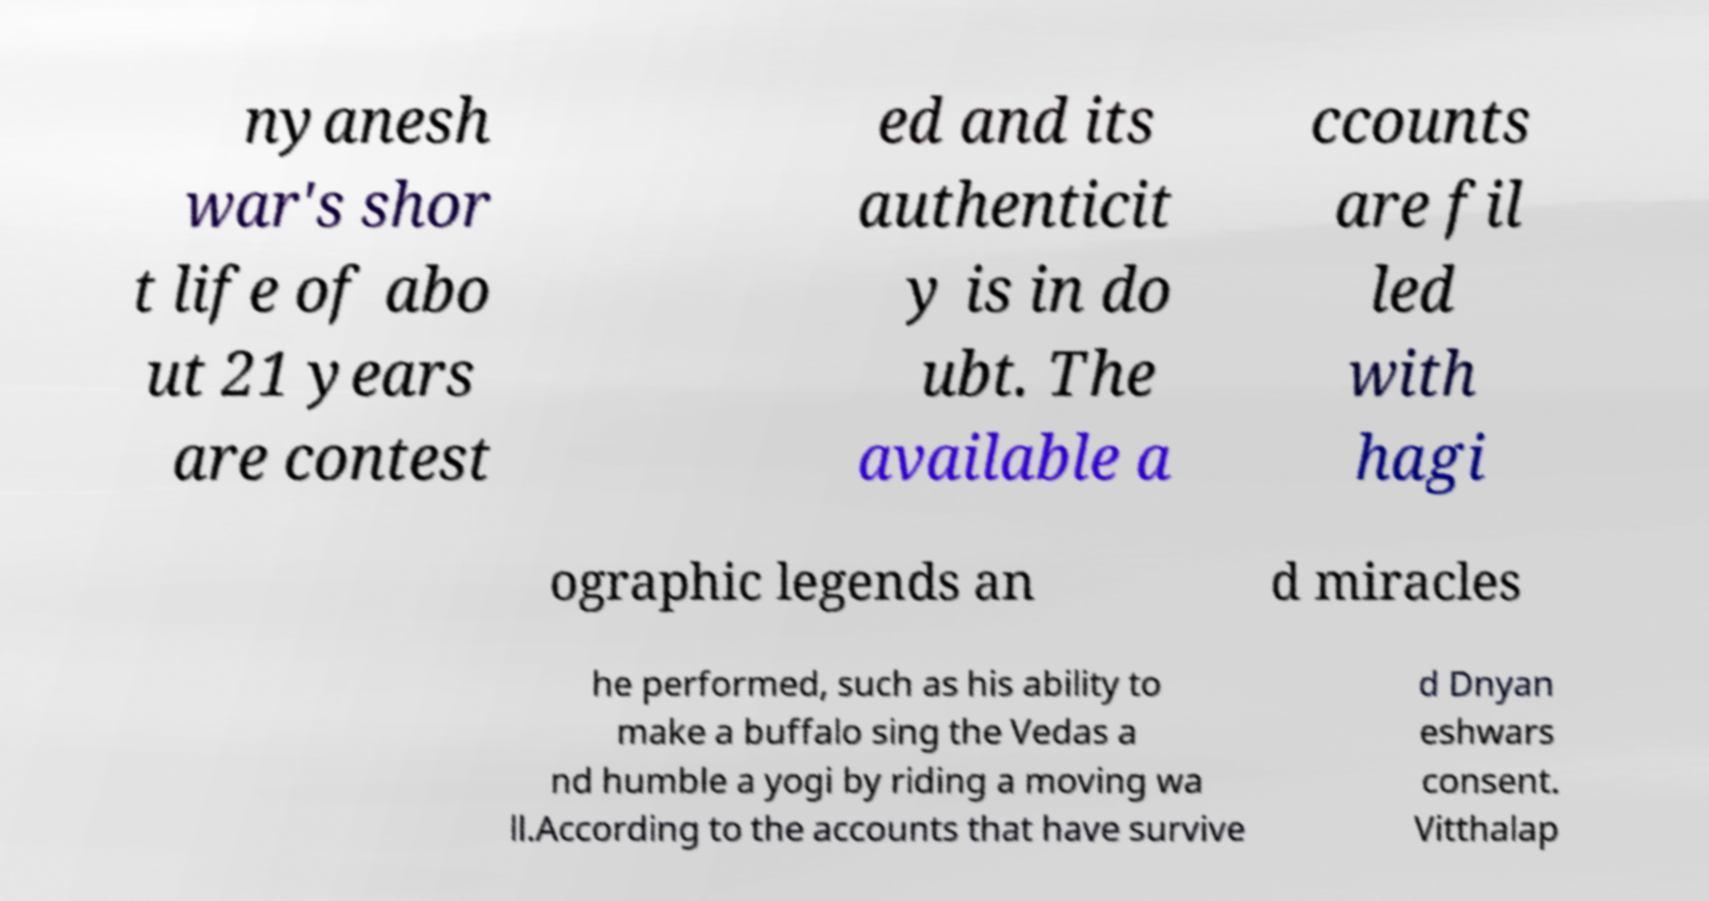What messages or text are displayed in this image? I need them in a readable, typed format. nyanesh war's shor t life of abo ut 21 years are contest ed and its authenticit y is in do ubt. The available a ccounts are fil led with hagi ographic legends an d miracles he performed, such as his ability to make a buffalo sing the Vedas a nd humble a yogi by riding a moving wa ll.According to the accounts that have survive d Dnyan eshwars consent. Vitthalap 